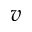<formula> <loc_0><loc_0><loc_500><loc_500>v</formula> 